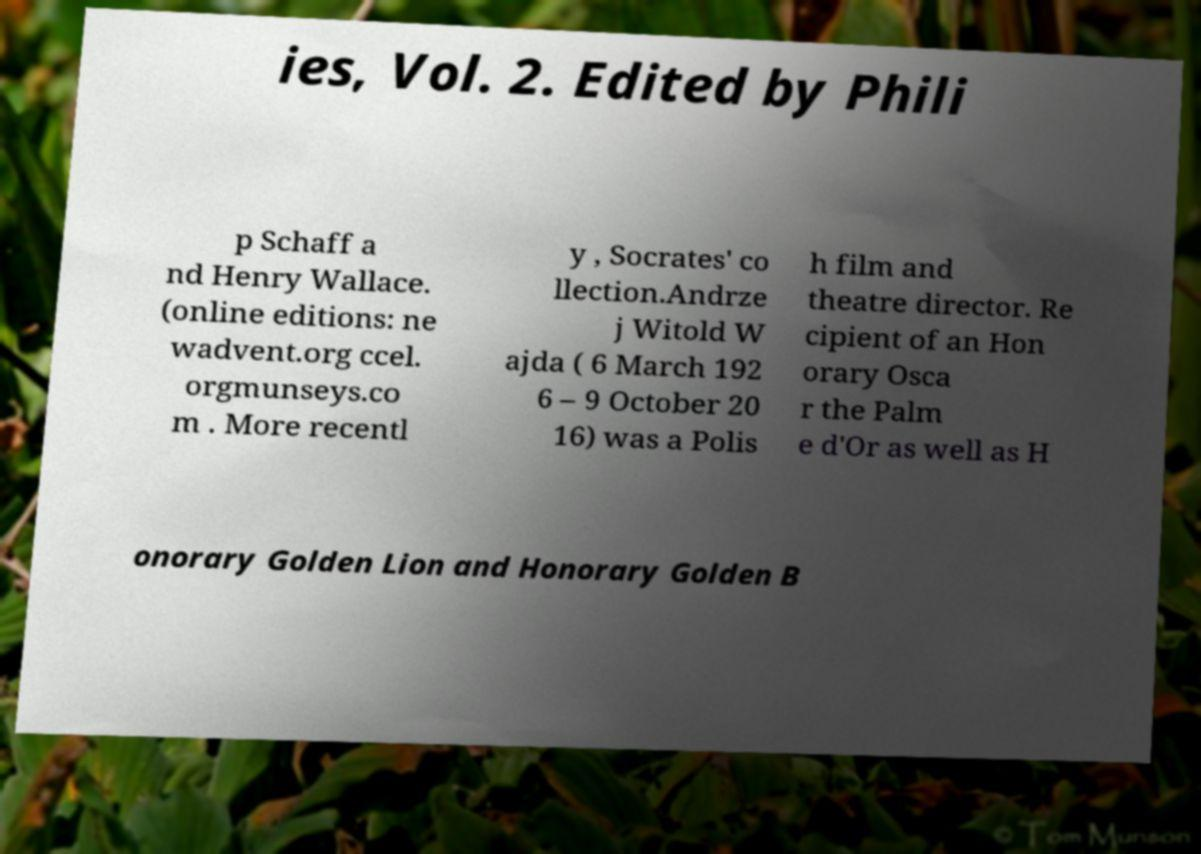Please read and relay the text visible in this image. What does it say? ies, Vol. 2. Edited by Phili p Schaff a nd Henry Wallace. (online editions: ne wadvent.org ccel. orgmunseys.co m . More recentl y , Socrates' co llection.Andrze j Witold W ajda ( 6 March 192 6 – 9 October 20 16) was a Polis h film and theatre director. Re cipient of an Hon orary Osca r the Palm e d'Or as well as H onorary Golden Lion and Honorary Golden B 